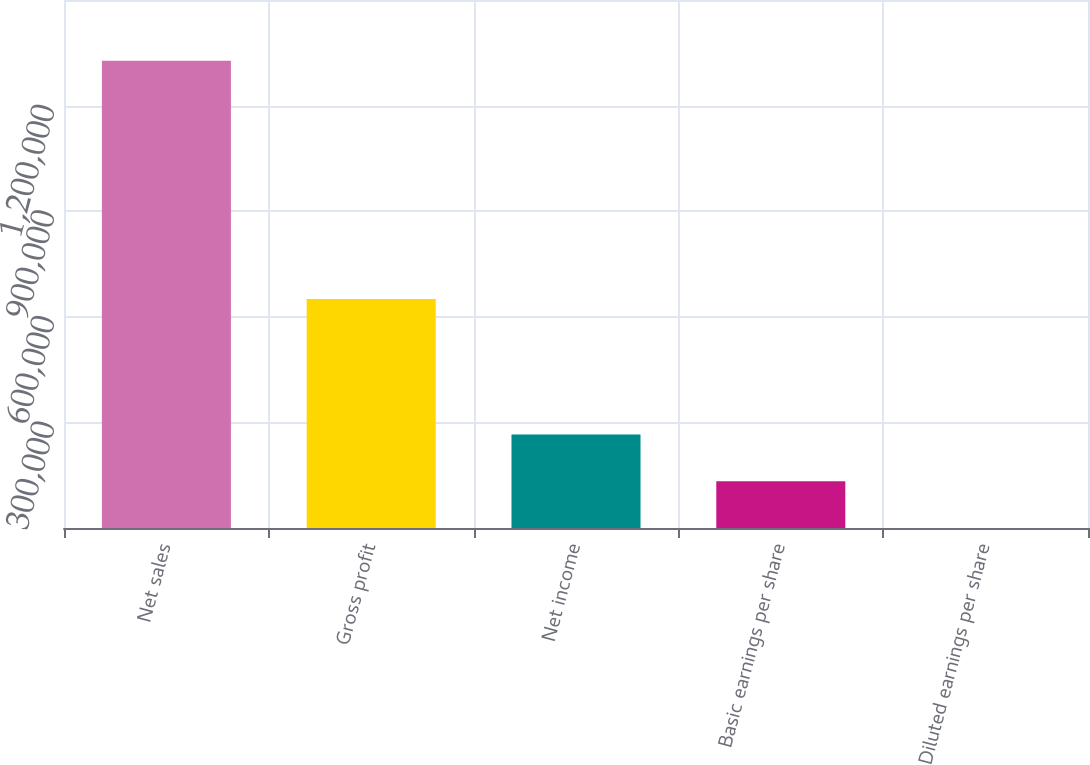Convert chart. <chart><loc_0><loc_0><loc_500><loc_500><bar_chart><fcel>Net sales<fcel>Gross profit<fcel>Net income<fcel>Basic earnings per share<fcel>Diluted earnings per share<nl><fcel>1.32757e+06<fcel>650738<fcel>265515<fcel>132758<fcel>0.9<nl></chart> 